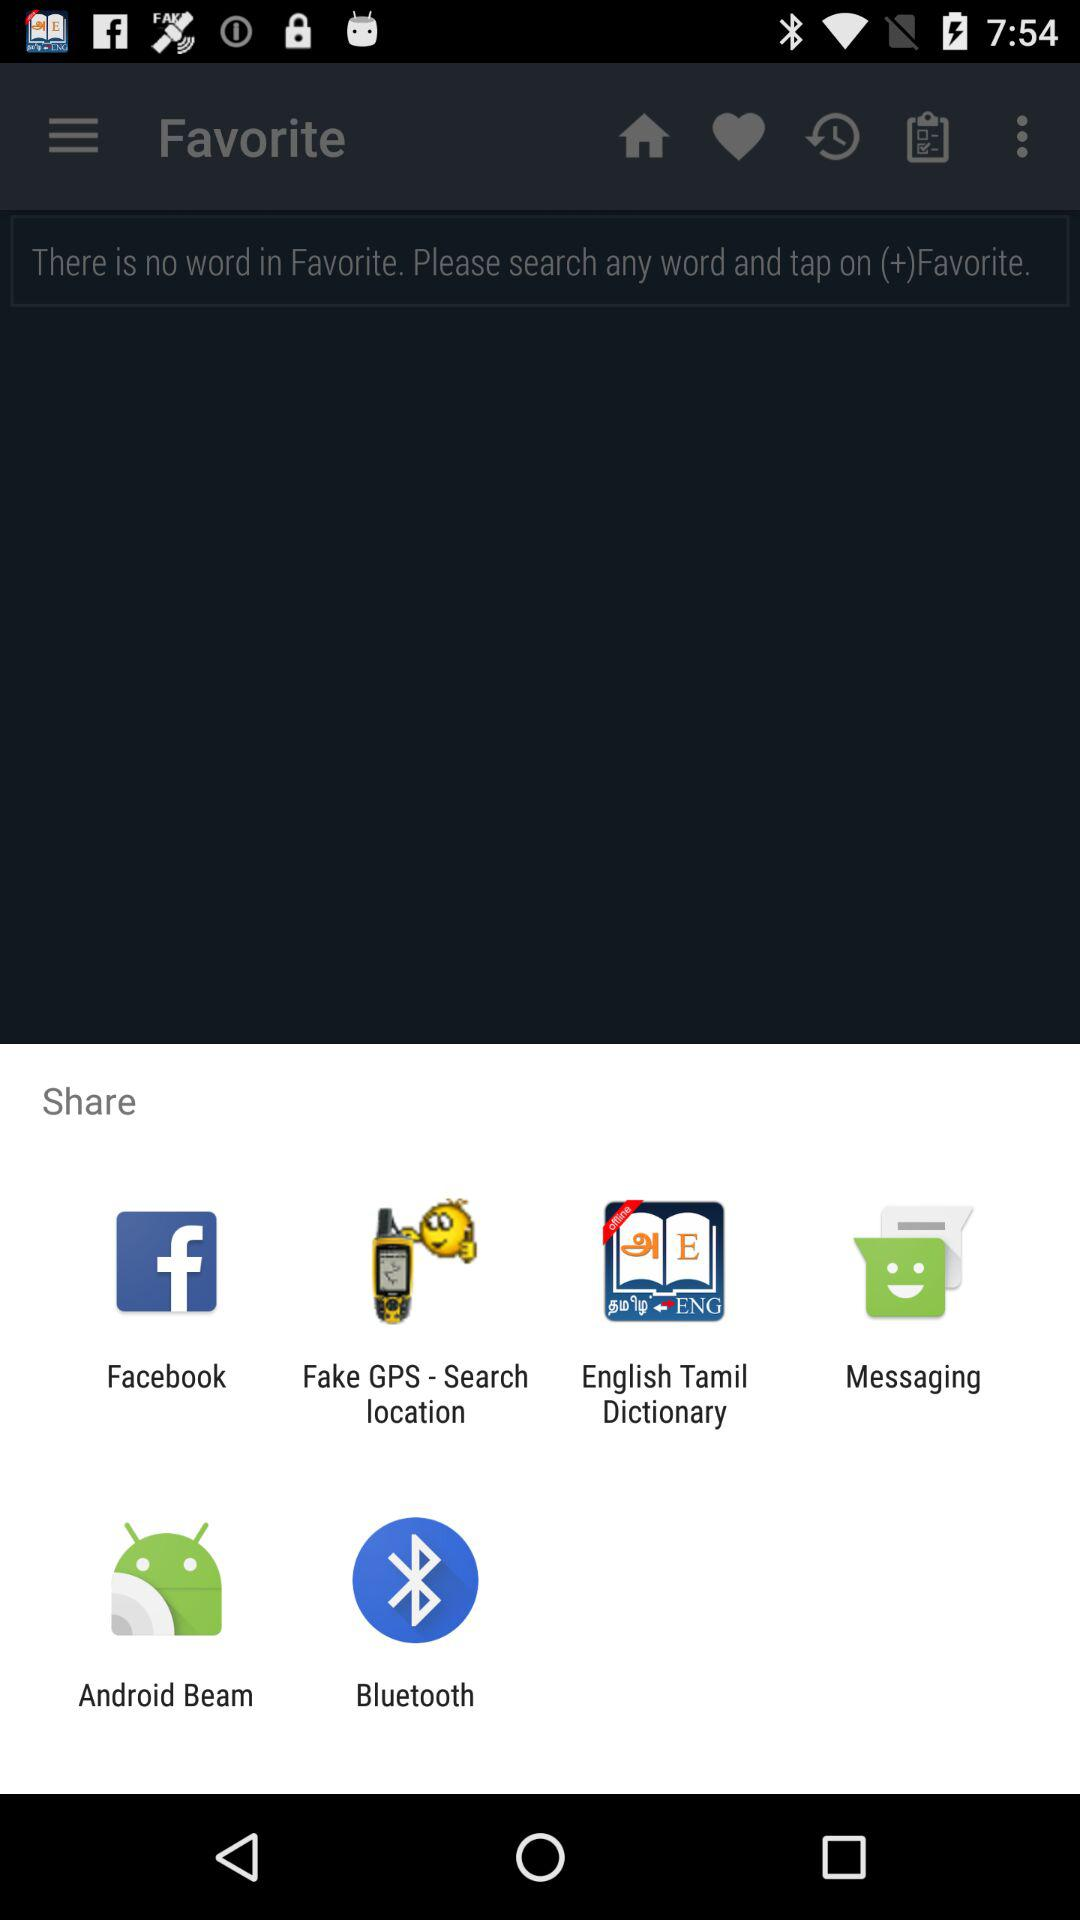What are the apps to share? The apps to share are "Facebook", "Fake GPS-Search location", "English Tamil Dictionary", "Messaging", "Android Beam", and "Bluetooth". 